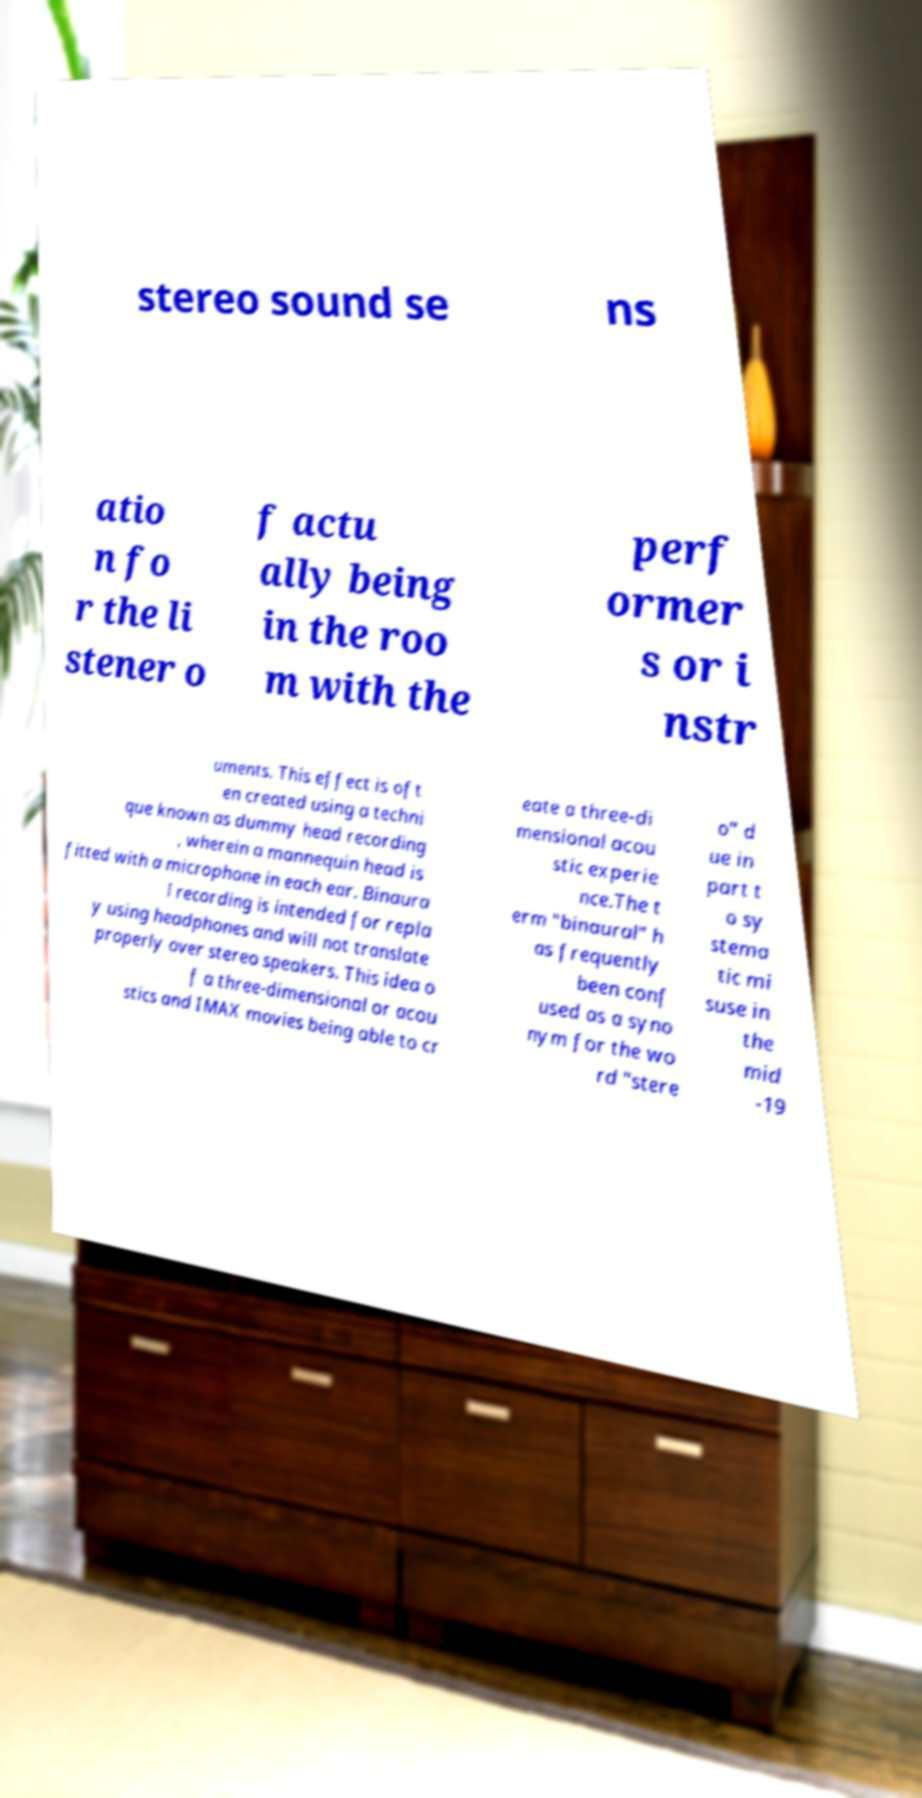Can you accurately transcribe the text from the provided image for me? stereo sound se ns atio n fo r the li stener o f actu ally being in the roo m with the perf ormer s or i nstr uments. This effect is oft en created using a techni que known as dummy head recording , wherein a mannequin head is fitted with a microphone in each ear. Binaura l recording is intended for repla y using headphones and will not translate properly over stereo speakers. This idea o f a three-dimensional or acou stics and IMAX movies being able to cr eate a three-di mensional acou stic experie nce.The t erm "binaural" h as frequently been conf used as a syno nym for the wo rd "stere o" d ue in part t o sy stema tic mi suse in the mid -19 